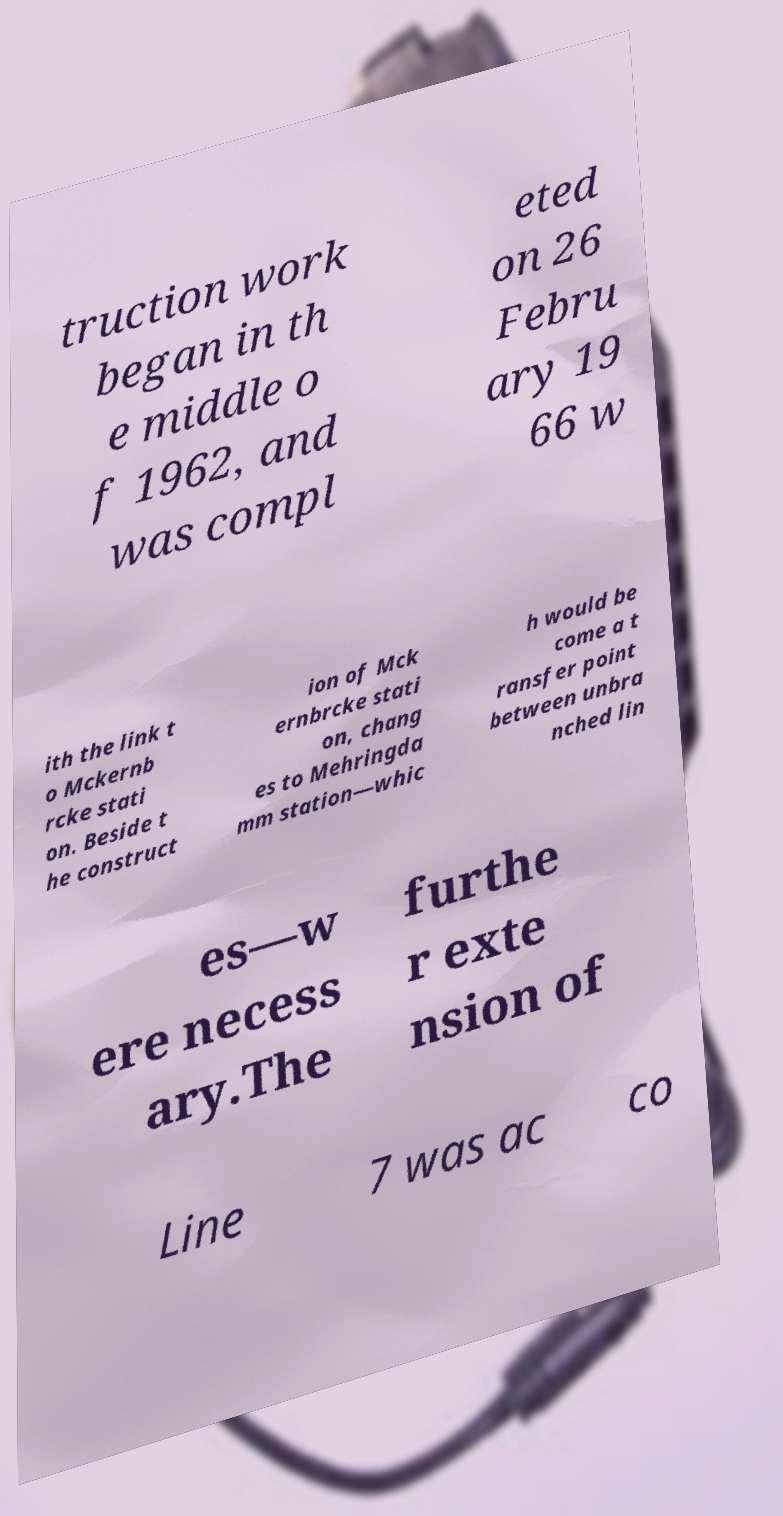There's text embedded in this image that I need extracted. Can you transcribe it verbatim? truction work began in th e middle o f 1962, and was compl eted on 26 Febru ary 19 66 w ith the link t o Mckernb rcke stati on. Beside t he construct ion of Mck ernbrcke stati on, chang es to Mehringda mm station—whic h would be come a t ransfer point between unbra nched lin es—w ere necess ary.The furthe r exte nsion of Line 7 was ac co 